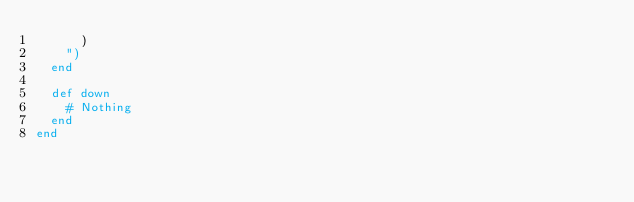Convert code to text. <code><loc_0><loc_0><loc_500><loc_500><_Ruby_>      )
    ")
  end

  def down
    # Nothing
  end
end
</code> 